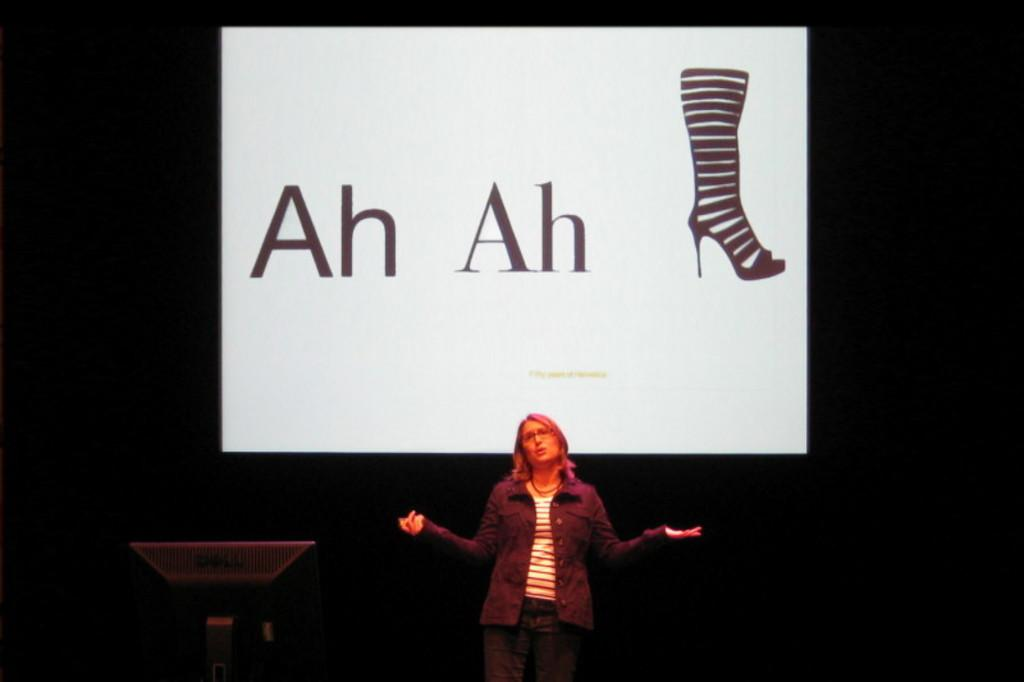Who is the main subject in the image? There is a lady standing in the middle of the image. What object is located beside the lady? There is a monitor beside the lady. What is visible on the screen behind the lady? There is a screen with text and an image behind the lady. How would you describe the overall lighting in the image? The background of the image is dark. How many people are in the crowd behind the lady in the image? There is no crowd present in the image; it only features the lady, the monitor, and the screen with text and an image. What type of arch can be seen in the image? There is no arch present in the image. 